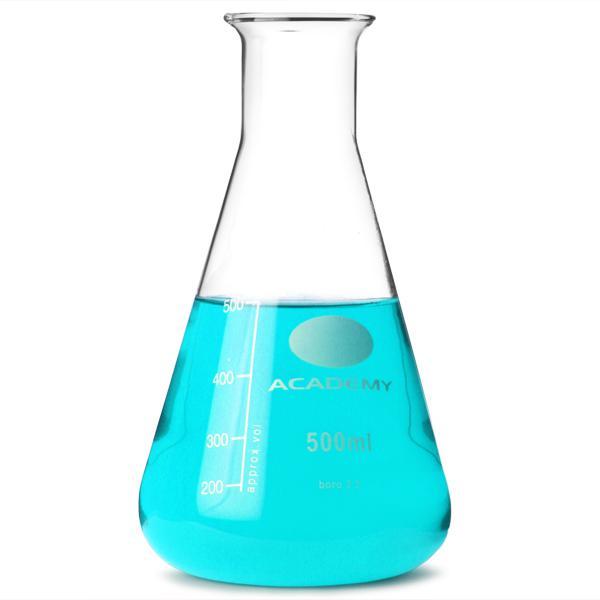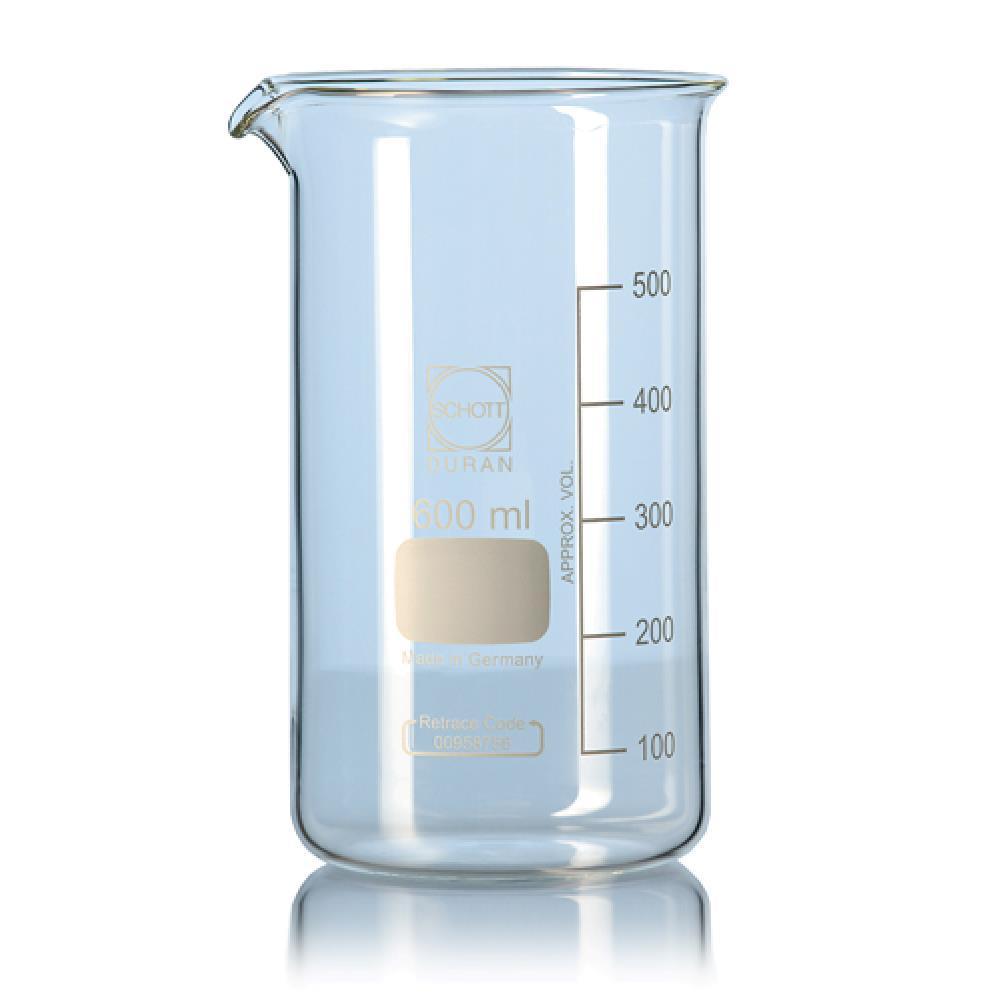The first image is the image on the left, the second image is the image on the right. Analyze the images presented: Is the assertion "There is at least one beaker looking bong in the image." valid? Answer yes or no. No. The first image is the image on the left, the second image is the image on the right. For the images displayed, is the sentence "One of the images has only a single flask, and it has blue liquid in it." factually correct? Answer yes or no. Yes. 